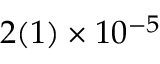<formula> <loc_0><loc_0><loc_500><loc_500>2 ( 1 ) \times 1 0 ^ { - 5 }</formula> 